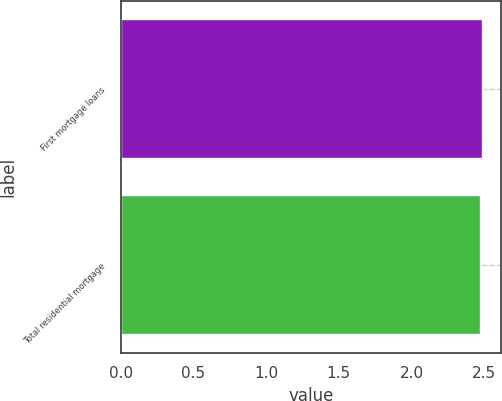Convert chart to OTSL. <chart><loc_0><loc_0><loc_500><loc_500><bar_chart><fcel>First mortgage loans<fcel>Total residential mortgage<nl><fcel>2.49<fcel>2.48<nl></chart> 